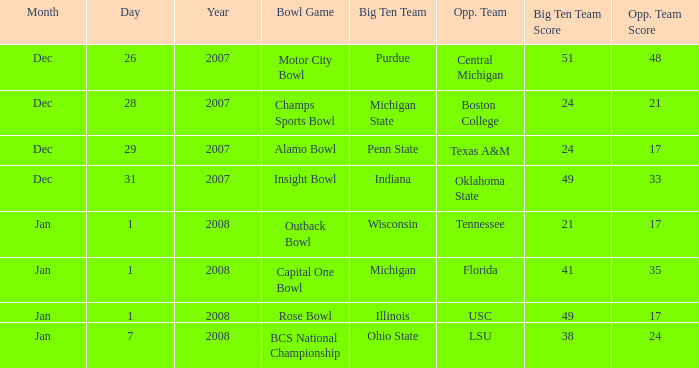What bowl game was played on Dec. 26, 2007? Motor City Bowl. 